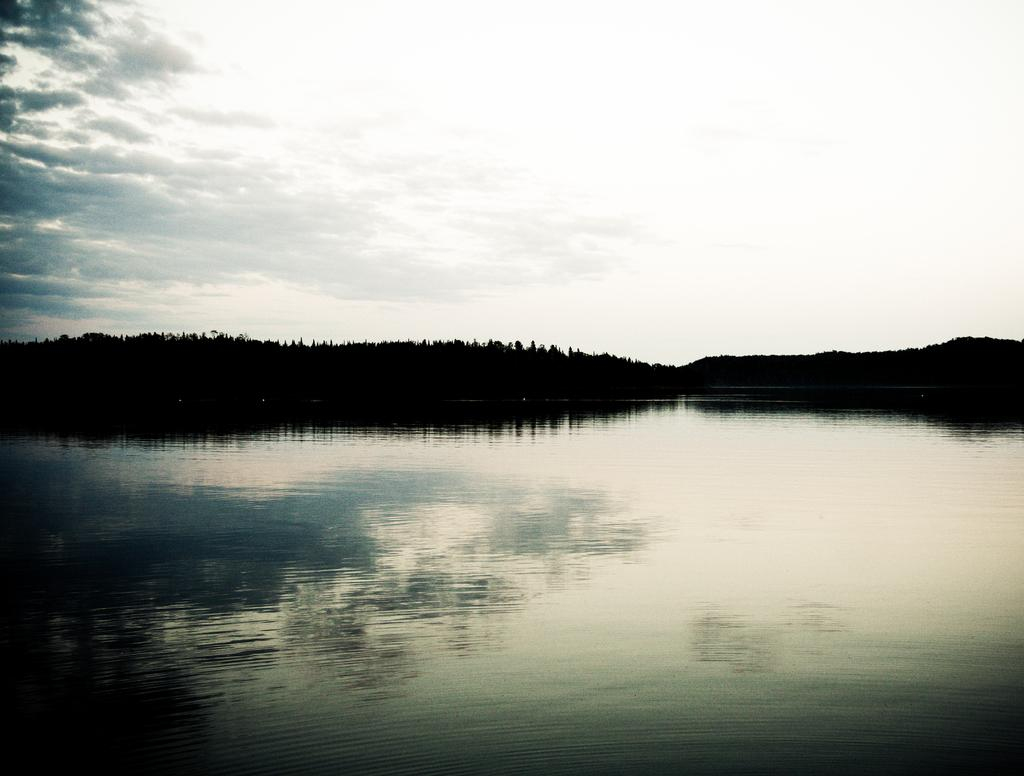What is the main feature in the center of the image? There is a lake in the center of the image. What can be seen in the background of the image? There are trees and the sky visible in the background of the image. What type of instrument is being played by the bird in the image? There is no bird or instrument present in the image. 